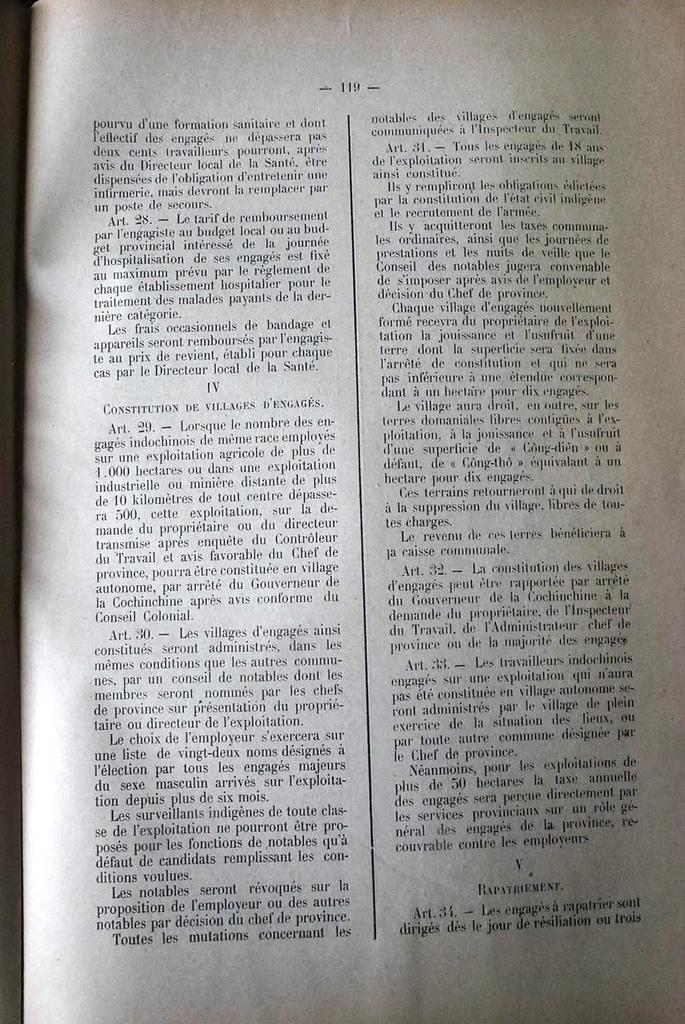<image>
Create a compact narrative representing the image presented. a long book sits opened to page 119 